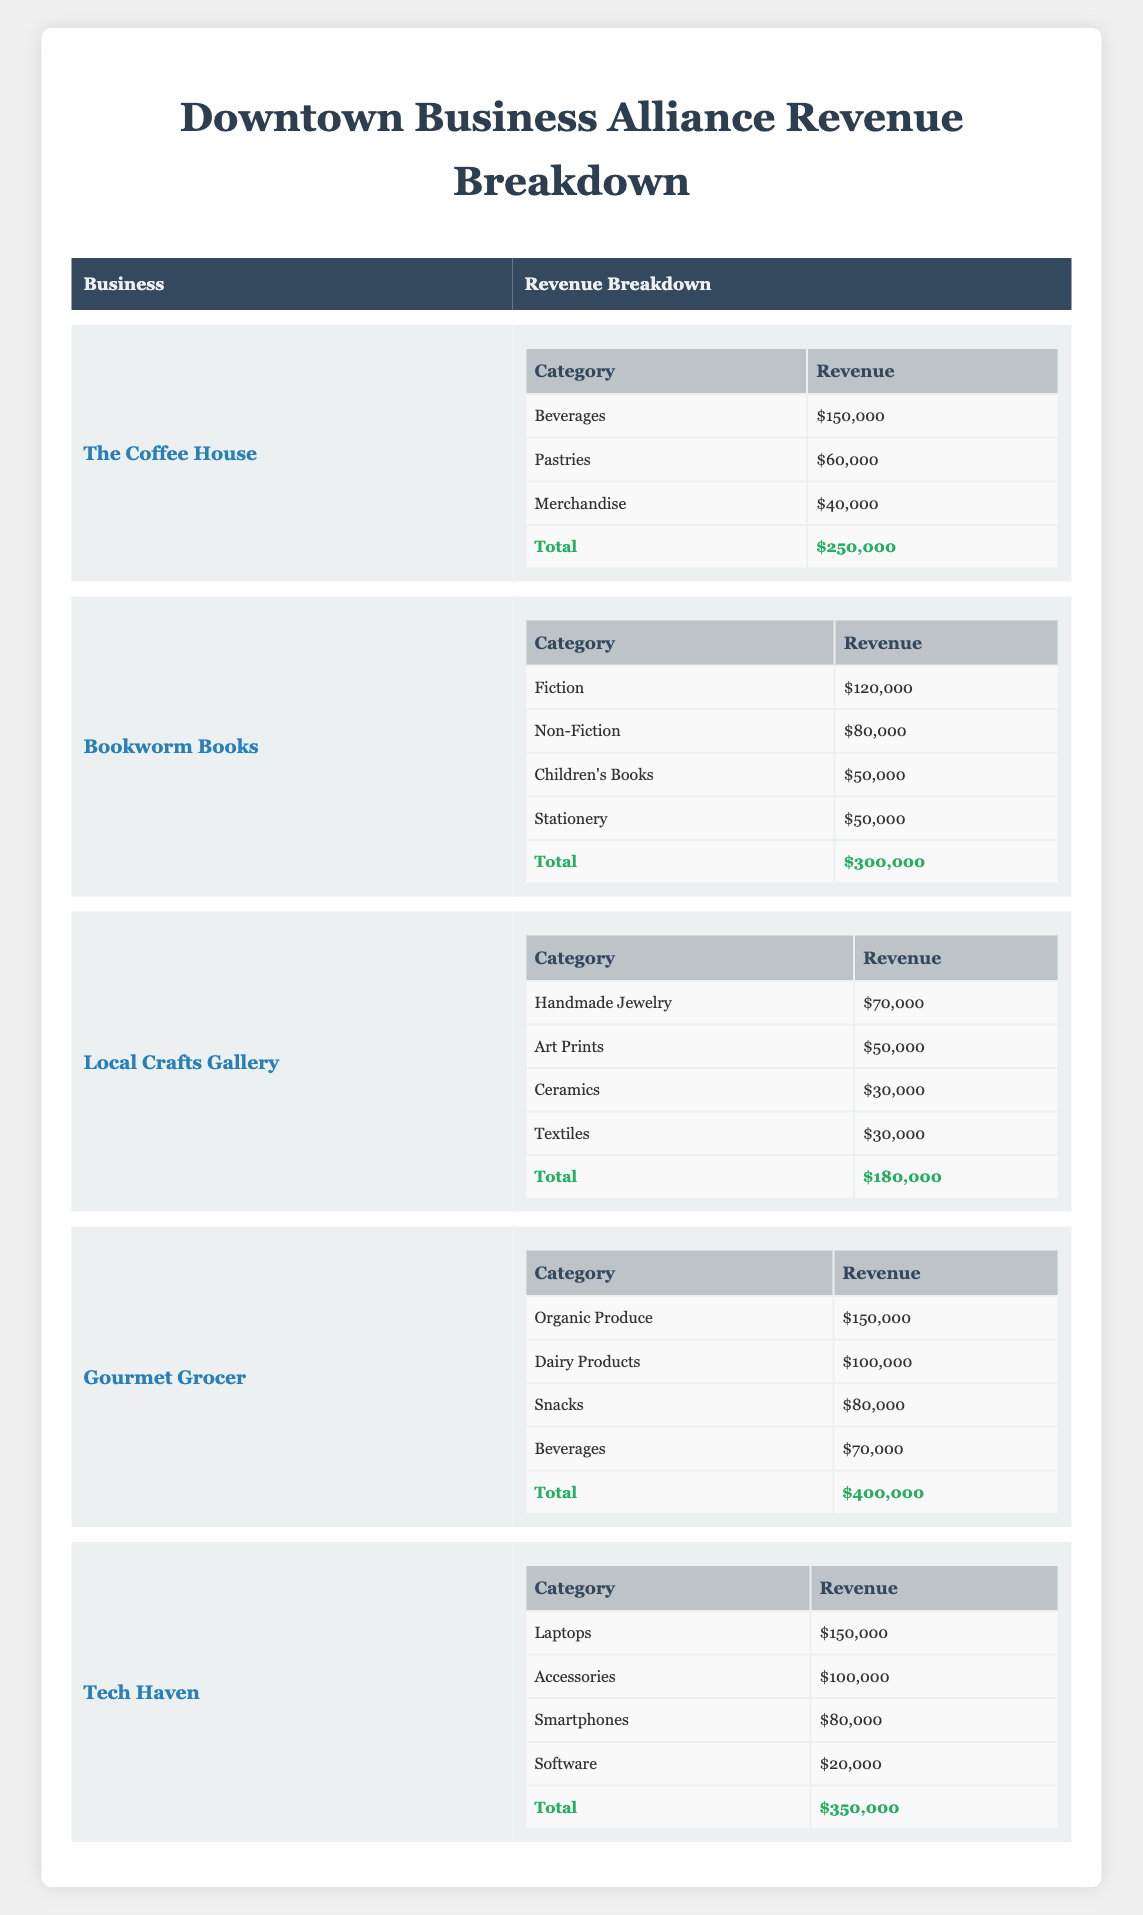What is the total revenue for The Coffee House? The table specifies The Coffee House's total revenue at the bottom of its revenue breakdown section, which is listed as $250,000.
Answer: $250,000 Which category generates the highest revenue for Gourmet Grocer? In the Gourmet Grocer section, the categories with revenues are listed. Organic Produce has the highest revenue at $150,000 compared to Dairy Products, Snacks, and Beverages.
Answer: Organic Produce What is the combined revenue from Pastries and Merchandise at The Coffee House? The revenues for Pastries and Merchandise at The Coffee House are $60,000 and $40,000 respectively. Adding these gives 60,000 + 40,000 = 100,000.
Answer: $100,000 Does Tech Haven earn more from Laptops than from Smartphones? In the Tech Haven category, revenue for Laptops is $150,000, while for Smartphones it's $80,000. Since 150,000 is greater than 80,000, the statement is true.
Answer: Yes What is the average revenue per category for Bookworm Books? Bookworm Books has four categories: Fiction ($120,000), Non-Fiction ($80,000), Children's Books ($50,000), and Stationery ($50,000). The total revenue is $300,000. There are 4 categories, so the average is 300,000 / 4 = 75,000.
Answer: $75,000 Which business has the lowest total revenue? By comparing the total revenues listed for each business, Local Crafts Gallery has the lowest total revenue of $180,000 compared to the others.
Answer: Local Crafts Gallery How much more does Gourmet Grocer earn compared to The Coffee House? Gourmet Grocer’s total revenue is $400,000 and The Coffee House’s is $250,000. Subtracting these gives 400,000 - 250,000 = 150,000, indicating Gourmet Grocer earns $150,000 more.
Answer: $150,000 Is the revenue from Dairy Products greater than that from Snacks at Gourmet Grocer? In the Gourmet Grocer category, Dairy Products revenue is $100,000 and Snacks revenue is $80,000. Since 100,000 is greater than 80,000, the answer is yes.
Answer: Yes What is the sum of revenues for all categories from Local Crafts Gallery? The category revenues for Local Crafts Gallery are Handmade Jewelry ($70,000), Art Prints ($50,000), Ceramics ($30,000), and Textiles ($30,000). Adding these gives 70,000 + 50,000 + 30,000 + 30,000 = 180,000, confirming the total revenue for the business.
Answer: $180,000 